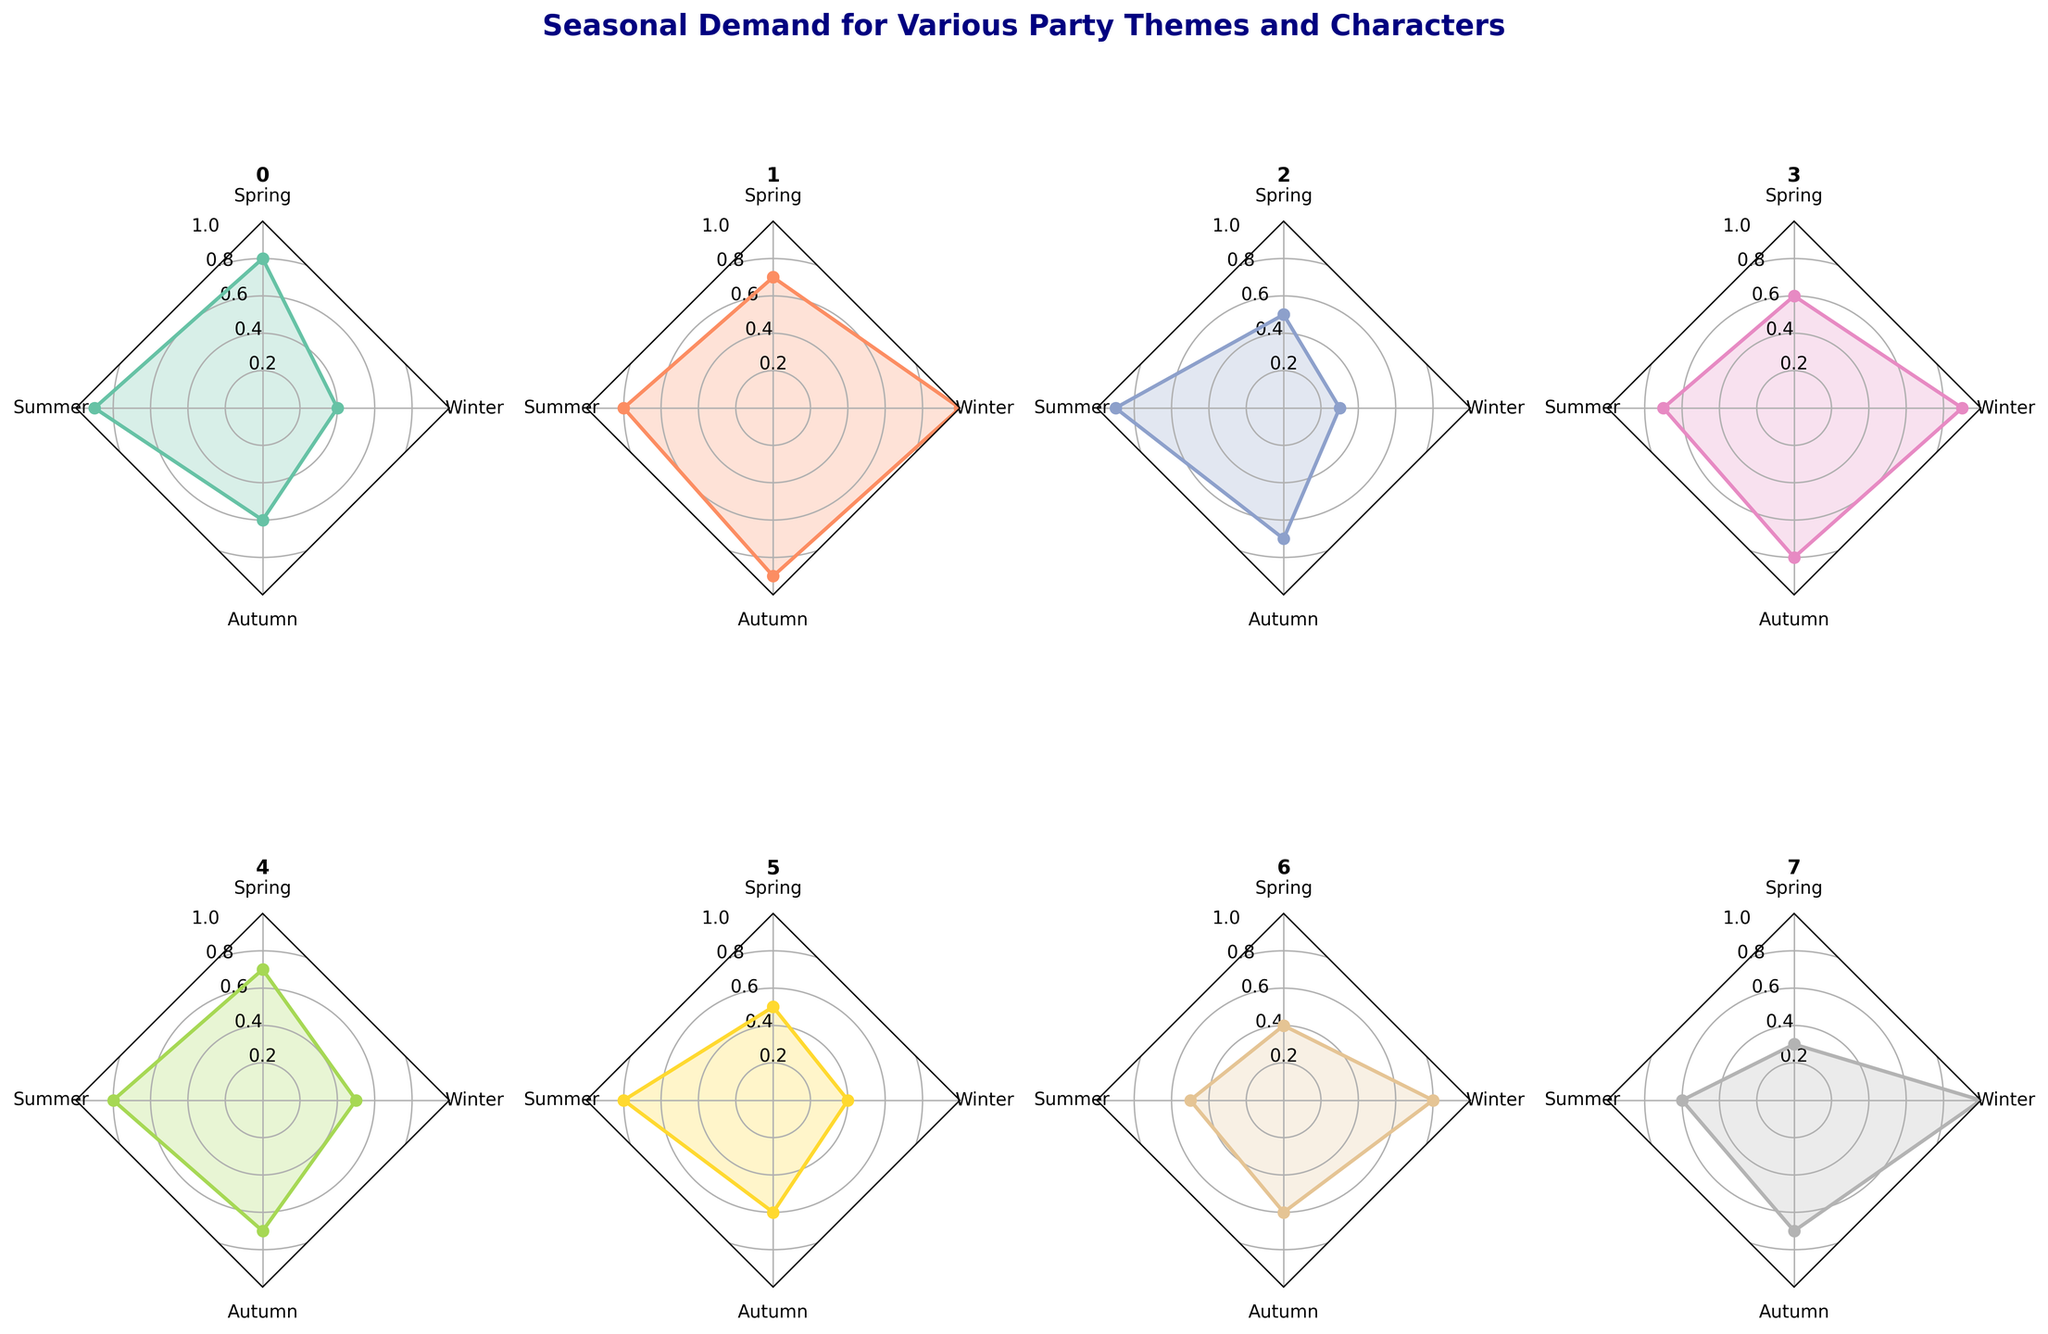What is the theme with the highest demand during Winter? By looking at the Winter axis in the radar chart for each theme, we can see that the Princesses and Holiday-Themed both reach the maximum value of 1.0
Answer: Princesses and Holiday-Themed Which theme has the lowest demand during Spring? By inspecting the Spring axis in the radar chart, we see that the Holiday-Themed theme has the lowest value at 0.3
Answer: Holiday-Themed What is the average demand for the Pirates theme across all seasons? Sum the demand values for Pirates across all seasons and then divide by the number of seasons (0.5 + 0.9 + 0.7 + 0.3) / 4 = 2.4 / 4 = 0.6
Answer: 0.6 How does demand for Villains in Summer compare to Winter? The value for Villains in Summer is 0.5, while in Winter it is 0.8. So, the demand in Winter is greater than in Summer
Answer: Winter has greater demand Which season shows the highest average demand across all themes? Calculate the average demand for each season. Sum the values for each season and divide by the number of themes to find the averages. Compare these averages to see which is highest. 
Spring: (0.8 + 0.7 + 0.5 + 0.6 + 0.7 + 0.5 + 0.4 + 0.3) / 8 = 4.5 / 8 = 0.5625
Summer: (0.9 + 0.8 + 0.9 + 0.7 + 0.8 + 0.8 + 0.5 + 0.6) / 8 = 6.0 / 8 = 0.75
Autumn: (0.6 + 0.9 + 0.7 + 0.8 + 0.7 + 0.6 + 0.6 + 0.7) / 8 = 5.6 / 8 = 0.7
Winter: (0.4 + 1.0 + 0.3 + 0.9 + 0.5 + 0.4 + 0.8 + 1.0) / 8 = 5.3 / 8 = 0.6625
So, Summer has the highest average demand.
Answer: Summer What is the difference in Autumn demand between Fantasy Creatures and Movie Characters? The Autumn demand for Fantasy Creatures is 0.8 while for Movie Characters it is 0.7. The difference is 0.8 - 0.7 = 0.1
Answer: 0.1 Among the Superheroes, Princesses, and Animals themes, which one has the lowest overall demand? Find the average demand for each theme across all seasons and then compare. 
Superheroes: (0.8 + 0.9 + 0.6 + 0.4) / 4 = 2.7 / 4 = 0.675
Princesses: (0.7 + 0.8 + 0.9 + 1.0) / 4 = 3.4 / 4 = 0.85
Animals: (0.5 + 0.8 + 0.6 + 0.4) / 4 = 2.3 / 4 = 0.575
Animals have the lowest average demand.
Answer: Animals During which season is the demand for Princesses the highest? By checking the radar chart for the Princesses theme, we can see the highest value is in Winter at 1.0
Answer: Winter 